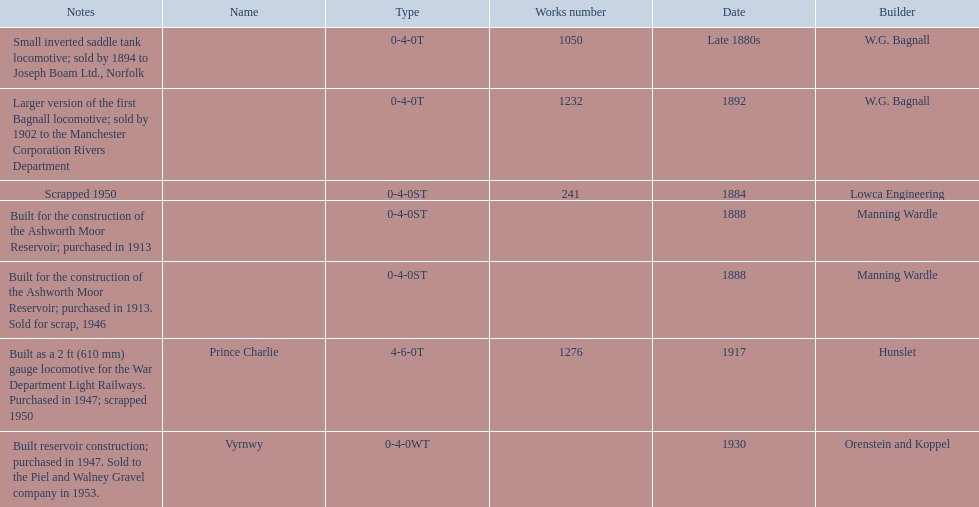List each of the builder's that had a locomotive scrapped. Lowca Engineering, Manning Wardle, Hunslet. 